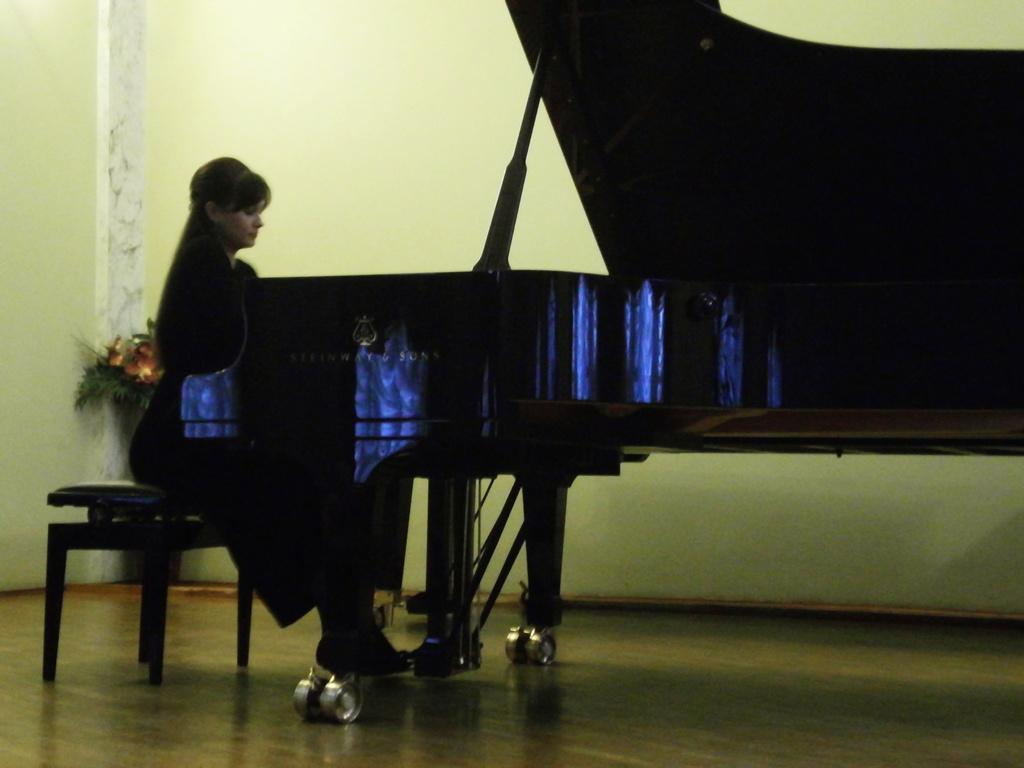Where was the image taken? The image was taken in a room. Who is present in the image? There is a girl in the image. What is the girl doing in the image? The girl is sitting on a chair and playing a piano. What can be seen in the background of the image? There is a wall and a decorative element in the background of the image. How many astronauts are visible in the image? There are no astronauts present in the image; it features a girl playing a piano in a room. What type of competition is the girl participating in within the image? There is no competition depicted in the image; the girl is simply playing a piano. 